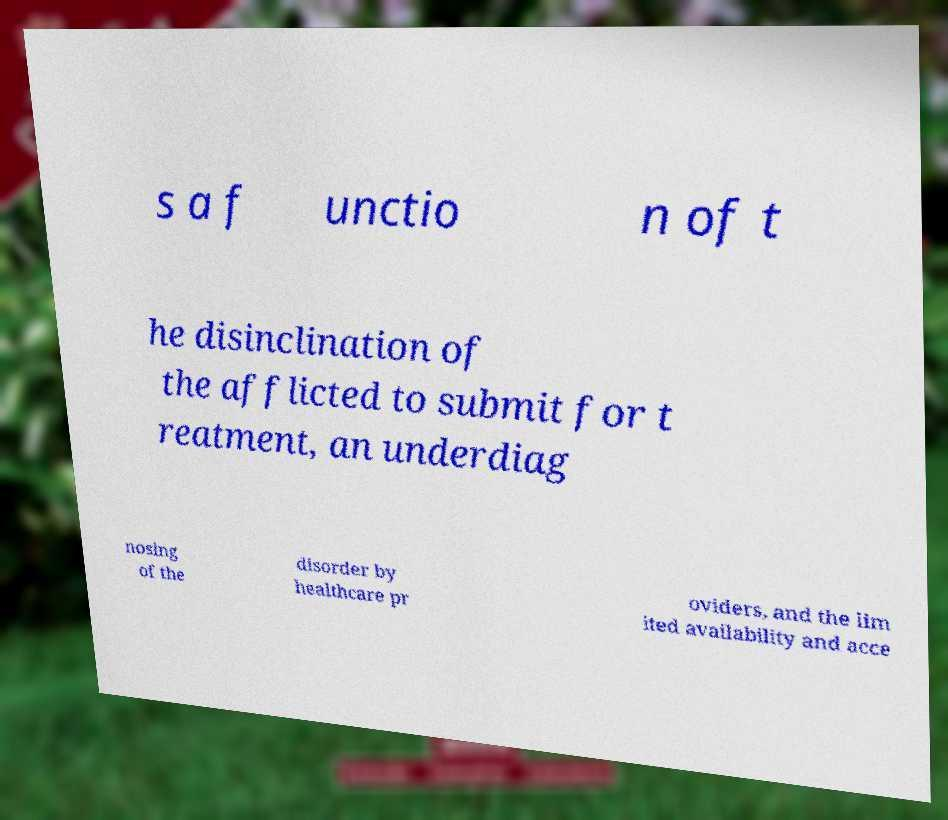For documentation purposes, I need the text within this image transcribed. Could you provide that? s a f unctio n of t he disinclination of the afflicted to submit for t reatment, an underdiag nosing of the disorder by healthcare pr oviders, and the lim ited availability and acce 